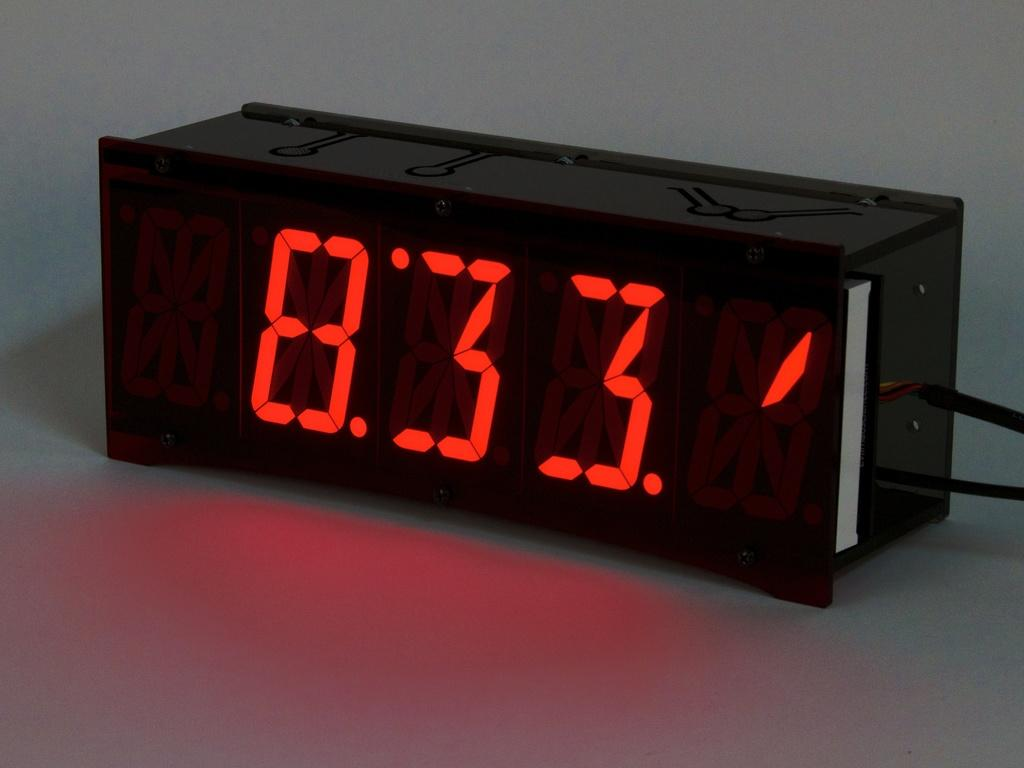<image>
Create a compact narrative representing the image presented. A black digital clock reads 8:33 in red. 